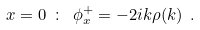Convert formula to latex. <formula><loc_0><loc_0><loc_500><loc_500>x = 0 \ \colon \ \phi ^ { + } _ { x } = - 2 i k \rho ( k ) \ .</formula> 